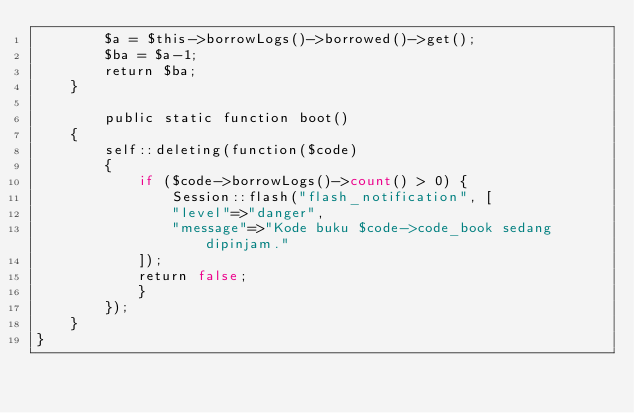<code> <loc_0><loc_0><loc_500><loc_500><_PHP_>		$a = $this->borrowLogs()->borrowed()->get();
		$ba = $a-1;
		return $ba;
	}

	    public static function boot()
    {
        self::deleting(function($code)
        {
            if ($code->borrowLogs()->count() > 0) {
                Session::flash("flash_notification", [
                "level"=>"danger",
                "message"=>"Kode buku $code->code_book sedang dipinjam."
            ]);
            return false;
            }
        });
    }
}
</code> 